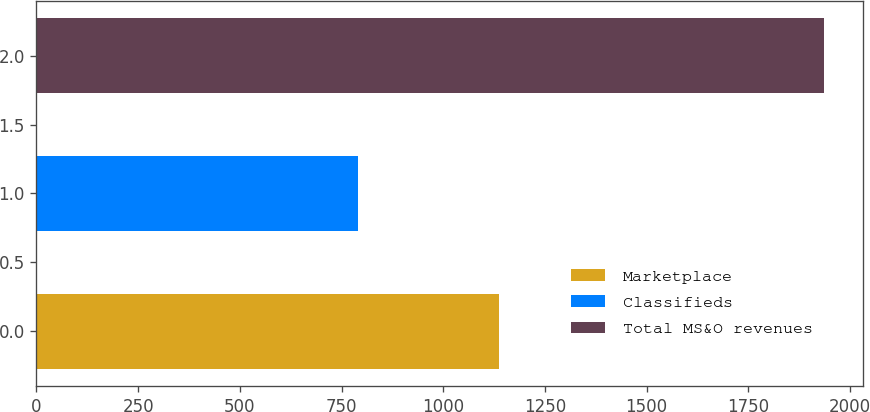<chart> <loc_0><loc_0><loc_500><loc_500><bar_chart><fcel>Marketplace<fcel>Classifieds<fcel>Total MS&O revenues<nl><fcel>1137<fcel>791<fcel>1935<nl></chart> 